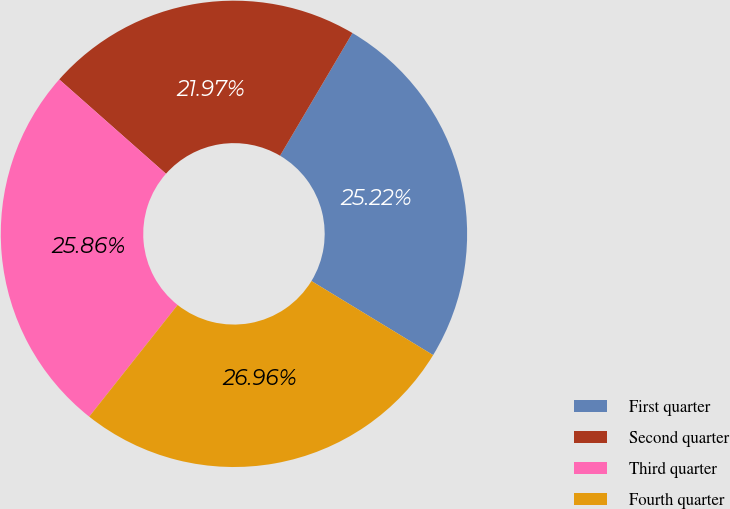Convert chart. <chart><loc_0><loc_0><loc_500><loc_500><pie_chart><fcel>First quarter<fcel>Second quarter<fcel>Third quarter<fcel>Fourth quarter<nl><fcel>25.22%<fcel>21.97%<fcel>25.86%<fcel>26.96%<nl></chart> 